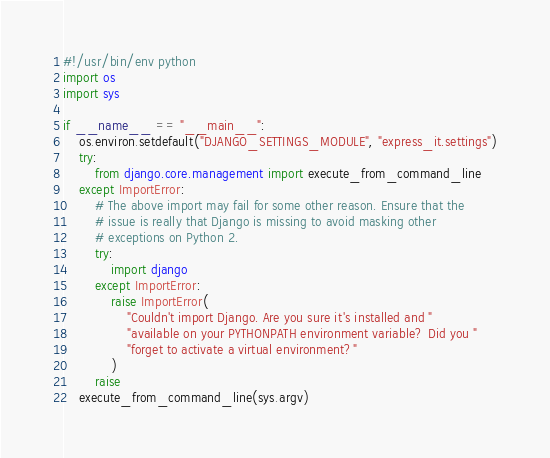<code> <loc_0><loc_0><loc_500><loc_500><_Python_>#!/usr/bin/env python
import os
import sys

if __name__ == "__main__":
    os.environ.setdefault("DJANGO_SETTINGS_MODULE", "express_it.settings")
    try:
        from django.core.management import execute_from_command_line
    except ImportError:
        # The above import may fail for some other reason. Ensure that the
        # issue is really that Django is missing to avoid masking other
        # exceptions on Python 2.
        try:
            import django
        except ImportError:
            raise ImportError(
                "Couldn't import Django. Are you sure it's installed and "
                "available on your PYTHONPATH environment variable? Did you "
                "forget to activate a virtual environment?"
            )
        raise
    execute_from_command_line(sys.argv)
</code> 